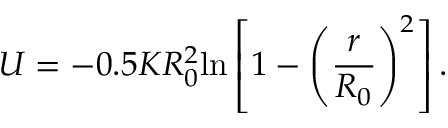<formula> <loc_0><loc_0><loc_500><loc_500>U = - 0 . 5 K R _ { 0 } ^ { 2 } \ln \left [ 1 - \left ( \frac { r } { R _ { 0 } } \right ) ^ { 2 } \right ] .</formula> 